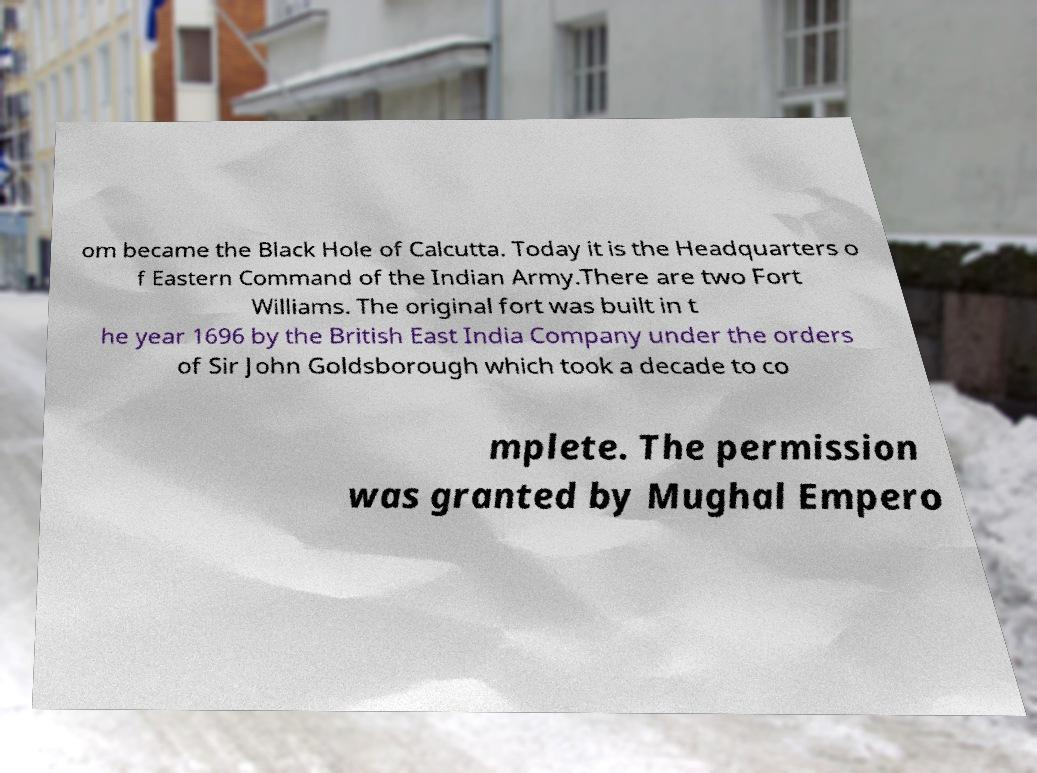Could you extract and type out the text from this image? om became the Black Hole of Calcutta. Today it is the Headquarters o f Eastern Command of the Indian Army.There are two Fort Williams. The original fort was built in t he year 1696 by the British East India Company under the orders of Sir John Goldsborough which took a decade to co mplete. The permission was granted by Mughal Empero 